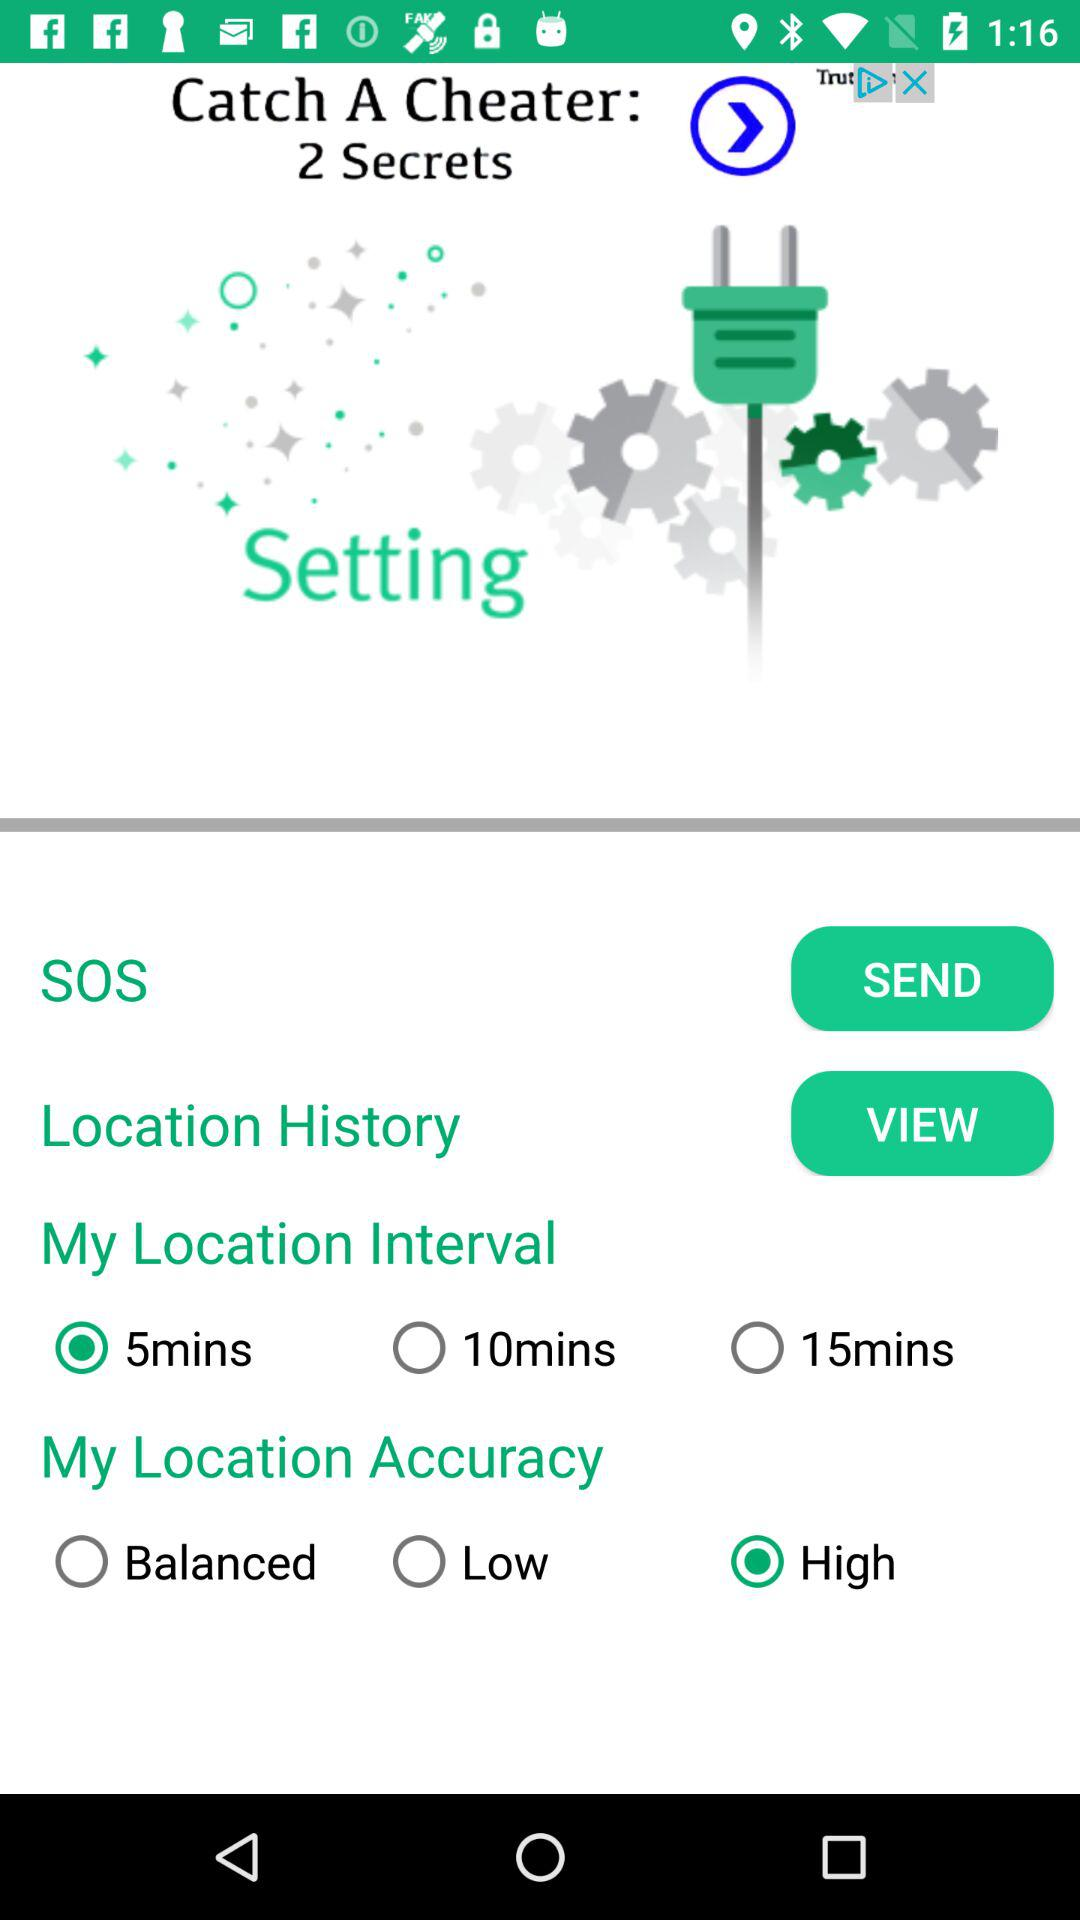What location interval is selected? The selected location interval is "5mins". 